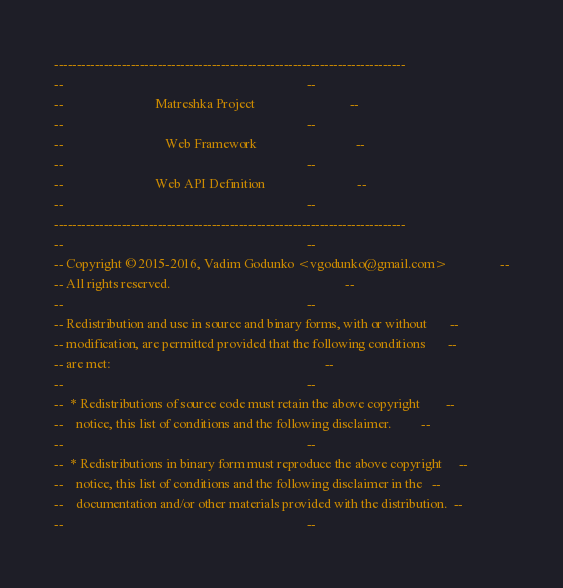Convert code to text. <code><loc_0><loc_0><loc_500><loc_500><_Ada_>------------------------------------------------------------------------------
--                                                                          --
--                            Matreshka Project                             --
--                                                                          --
--                               Web Framework                              --
--                                                                          --
--                            Web API Definition                            --
--                                                                          --
------------------------------------------------------------------------------
--                                                                          --
-- Copyright © 2015-2016, Vadim Godunko <vgodunko@gmail.com>                --
-- All rights reserved.                                                     --
--                                                                          --
-- Redistribution and use in source and binary forms, with or without       --
-- modification, are permitted provided that the following conditions       --
-- are met:                                                                 --
--                                                                          --
--  * Redistributions of source code must retain the above copyright        --
--    notice, this list of conditions and the following disclaimer.         --
--                                                                          --
--  * Redistributions in binary form must reproduce the above copyright     --
--    notice, this list of conditions and the following disclaimer in the   --
--    documentation and/or other materials provided with the distribution.  --
--                                                                          --</code> 